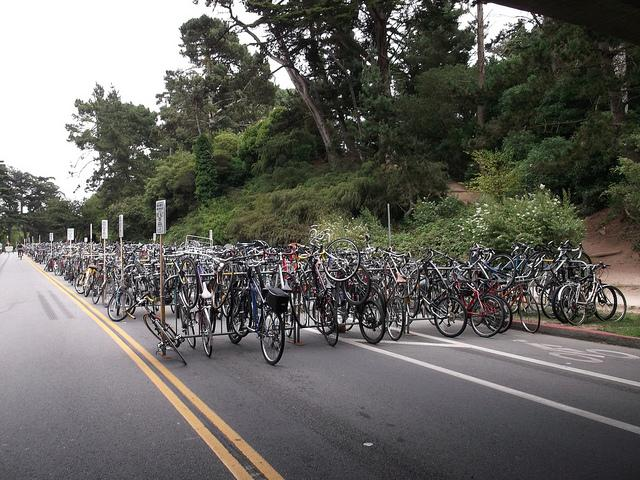What company is known for making the abundant items here? huffy 